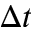Convert formula to latex. <formula><loc_0><loc_0><loc_500><loc_500>\Delta t</formula> 